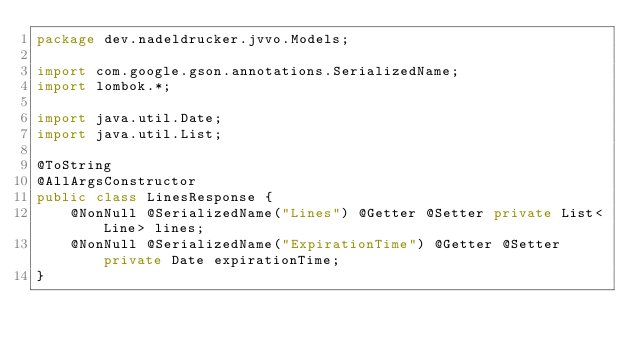<code> <loc_0><loc_0><loc_500><loc_500><_Java_>package dev.nadeldrucker.jvvo.Models;

import com.google.gson.annotations.SerializedName;
import lombok.*;

import java.util.Date;
import java.util.List;

@ToString
@AllArgsConstructor
public class LinesResponse {
    @NonNull @SerializedName("Lines") @Getter @Setter private List<Line> lines;
    @NonNull @SerializedName("ExpirationTime") @Getter @Setter private Date expirationTime;
}
</code> 